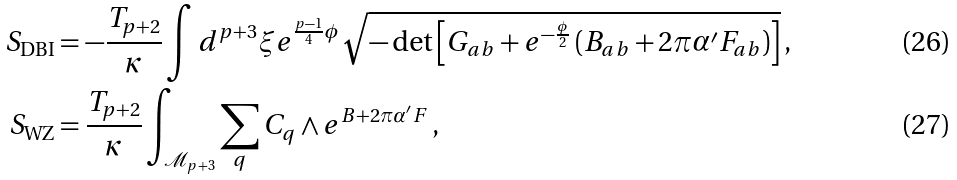<formula> <loc_0><loc_0><loc_500><loc_500>S _ { \text {DBI} } & = - \frac { T _ { p + 2 } } { \kappa } \int d ^ { p + 3 } \xi e ^ { \frac { p - 1 } { 4 } \phi } \sqrt { - \det \left [ G _ { a b } + e ^ { - \frac { \phi } { 2 } } \left ( B _ { a b } + 2 \pi \alpha ^ { \prime } F _ { a b } \right ) \right ] } \, , \\ S _ { \text {WZ} } & = \frac { T _ { p + 2 } } { \kappa } \int _ { \mathcal { M } _ { p + 3 } } \sum _ { q } C _ { q } \wedge e ^ { B + 2 \pi \alpha ^ { \prime } F } \, ,</formula> 